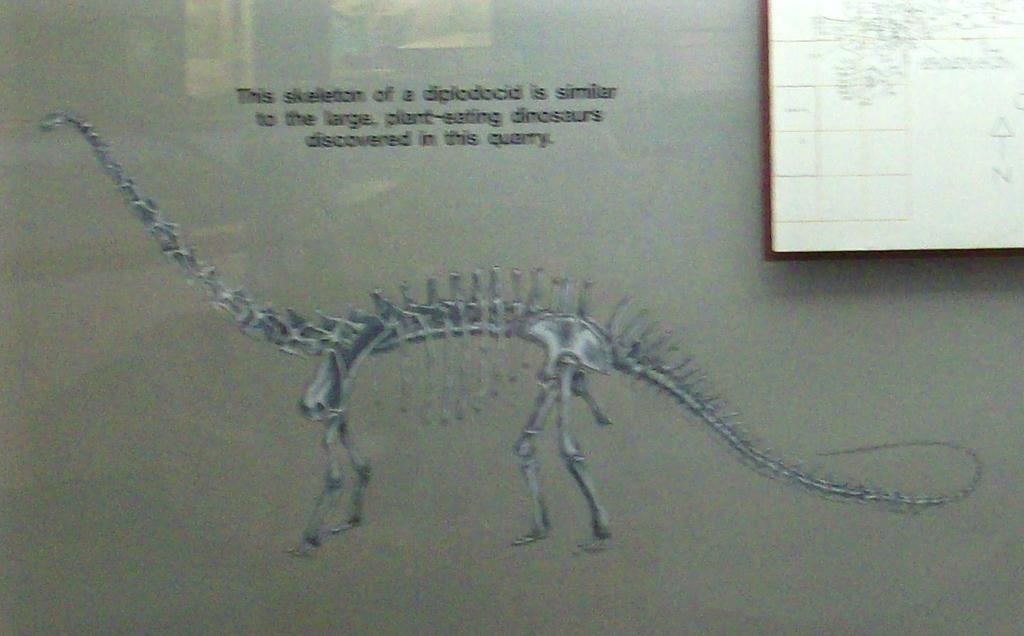<image>
Give a short and clear explanation of the subsequent image. A blurry skeleton of a Diplodocid on a gray background 